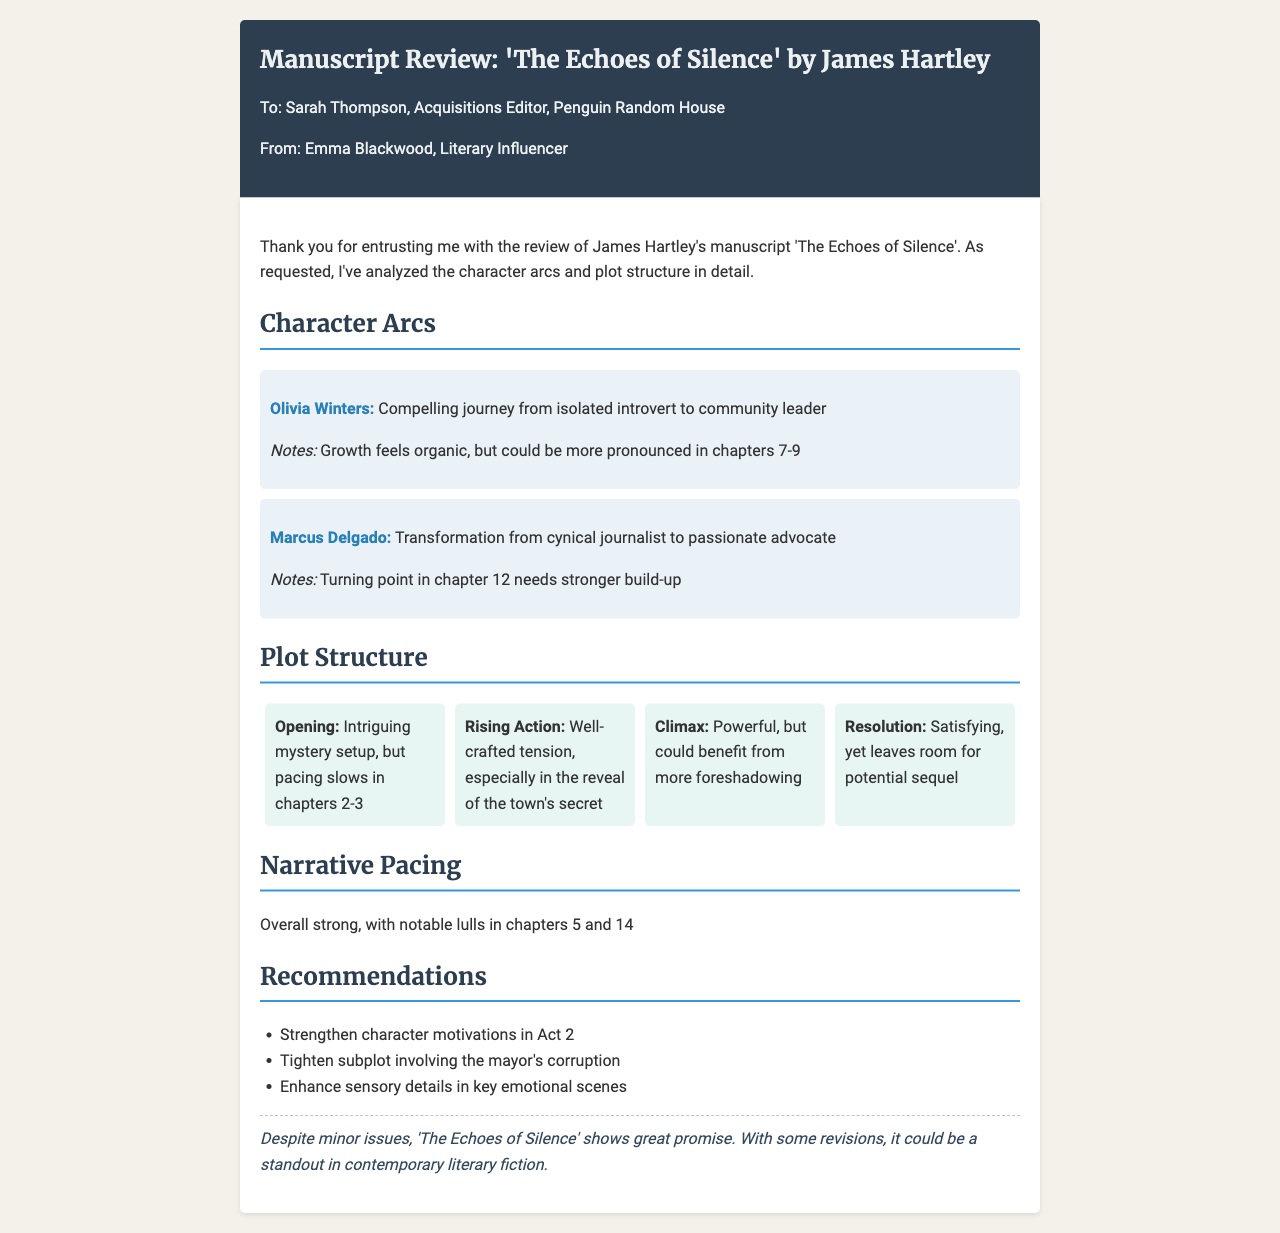What is the title of the manuscript? The title of the manuscript is specified in the document header.
Answer: The Echoes of Silence Who is the author of the manuscript? The author of the manuscript is mentioned in the title.
Answer: James Hartley What is the name of the character with an isolated journey? This character's journey is described in the character arcs section.
Answer: Olivia Winters In which chapter does Marcus Delgado's turning point occur? The chapter of Marcus Delgado's turning point is detailed in the character arc notes.
Answer: Chapter 12 What are the notable lulls in narrative pacing? The specific chapters with notable lulls are listed under narrative pacing.
Answer: Chapters 5 and 14 What recommendation is given regarding the mayor's subplot? The recommendation involves improvement of a specific plot point.
Answer: Tighten subplot involving the mayor's corruption What type of ending does the manuscript have? The resolution section describes the nature of the manuscript's ending.
Answer: Satisfying How many character arcs are detailed in the document? The document outlines a specific number of character arcs.
Answer: Two 